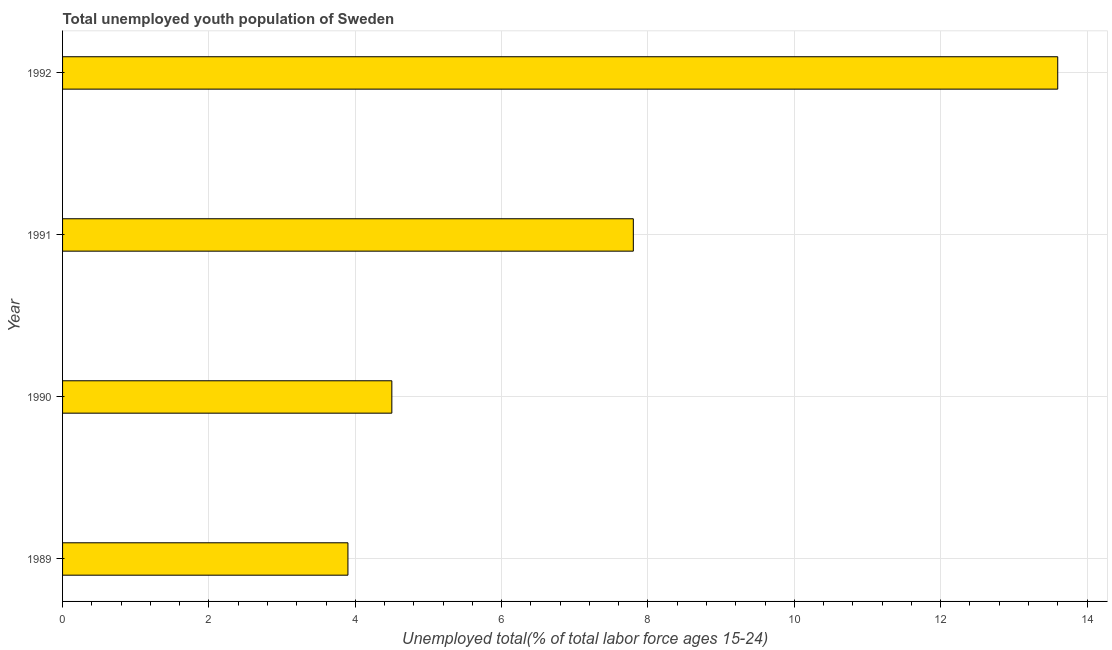What is the title of the graph?
Your answer should be compact. Total unemployed youth population of Sweden. What is the label or title of the X-axis?
Your answer should be compact. Unemployed total(% of total labor force ages 15-24). What is the unemployed youth in 1989?
Provide a short and direct response. 3.9. Across all years, what is the maximum unemployed youth?
Offer a very short reply. 13.6. Across all years, what is the minimum unemployed youth?
Your answer should be compact. 3.9. In which year was the unemployed youth maximum?
Ensure brevity in your answer.  1992. What is the sum of the unemployed youth?
Keep it short and to the point. 29.8. What is the difference between the unemployed youth in 1989 and 1992?
Provide a succinct answer. -9.7. What is the average unemployed youth per year?
Give a very brief answer. 7.45. What is the median unemployed youth?
Your response must be concise. 6.15. What is the ratio of the unemployed youth in 1989 to that in 1992?
Your answer should be compact. 0.29. Is the unemployed youth in 1990 less than that in 1991?
Keep it short and to the point. Yes. Is the difference between the unemployed youth in 1990 and 1992 greater than the difference between any two years?
Ensure brevity in your answer.  No. Is the sum of the unemployed youth in 1989 and 1992 greater than the maximum unemployed youth across all years?
Offer a terse response. Yes. What is the difference between the highest and the lowest unemployed youth?
Make the answer very short. 9.7. Are all the bars in the graph horizontal?
Offer a very short reply. Yes. What is the difference between two consecutive major ticks on the X-axis?
Keep it short and to the point. 2. What is the Unemployed total(% of total labor force ages 15-24) in 1989?
Your response must be concise. 3.9. What is the Unemployed total(% of total labor force ages 15-24) of 1991?
Provide a short and direct response. 7.8. What is the Unemployed total(% of total labor force ages 15-24) of 1992?
Your answer should be compact. 13.6. What is the difference between the Unemployed total(% of total labor force ages 15-24) in 1989 and 1990?
Your response must be concise. -0.6. What is the difference between the Unemployed total(% of total labor force ages 15-24) in 1989 and 1991?
Make the answer very short. -3.9. What is the difference between the Unemployed total(% of total labor force ages 15-24) in 1989 and 1992?
Your answer should be compact. -9.7. What is the difference between the Unemployed total(% of total labor force ages 15-24) in 1990 and 1992?
Give a very brief answer. -9.1. What is the difference between the Unemployed total(% of total labor force ages 15-24) in 1991 and 1992?
Your response must be concise. -5.8. What is the ratio of the Unemployed total(% of total labor force ages 15-24) in 1989 to that in 1990?
Make the answer very short. 0.87. What is the ratio of the Unemployed total(% of total labor force ages 15-24) in 1989 to that in 1992?
Make the answer very short. 0.29. What is the ratio of the Unemployed total(% of total labor force ages 15-24) in 1990 to that in 1991?
Your answer should be very brief. 0.58. What is the ratio of the Unemployed total(% of total labor force ages 15-24) in 1990 to that in 1992?
Provide a short and direct response. 0.33. What is the ratio of the Unemployed total(% of total labor force ages 15-24) in 1991 to that in 1992?
Offer a terse response. 0.57. 